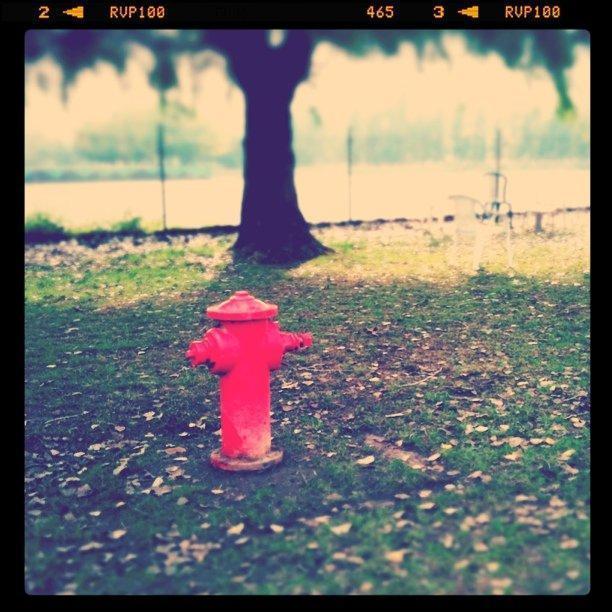How many open umbrellas are there?
Give a very brief answer. 0. 